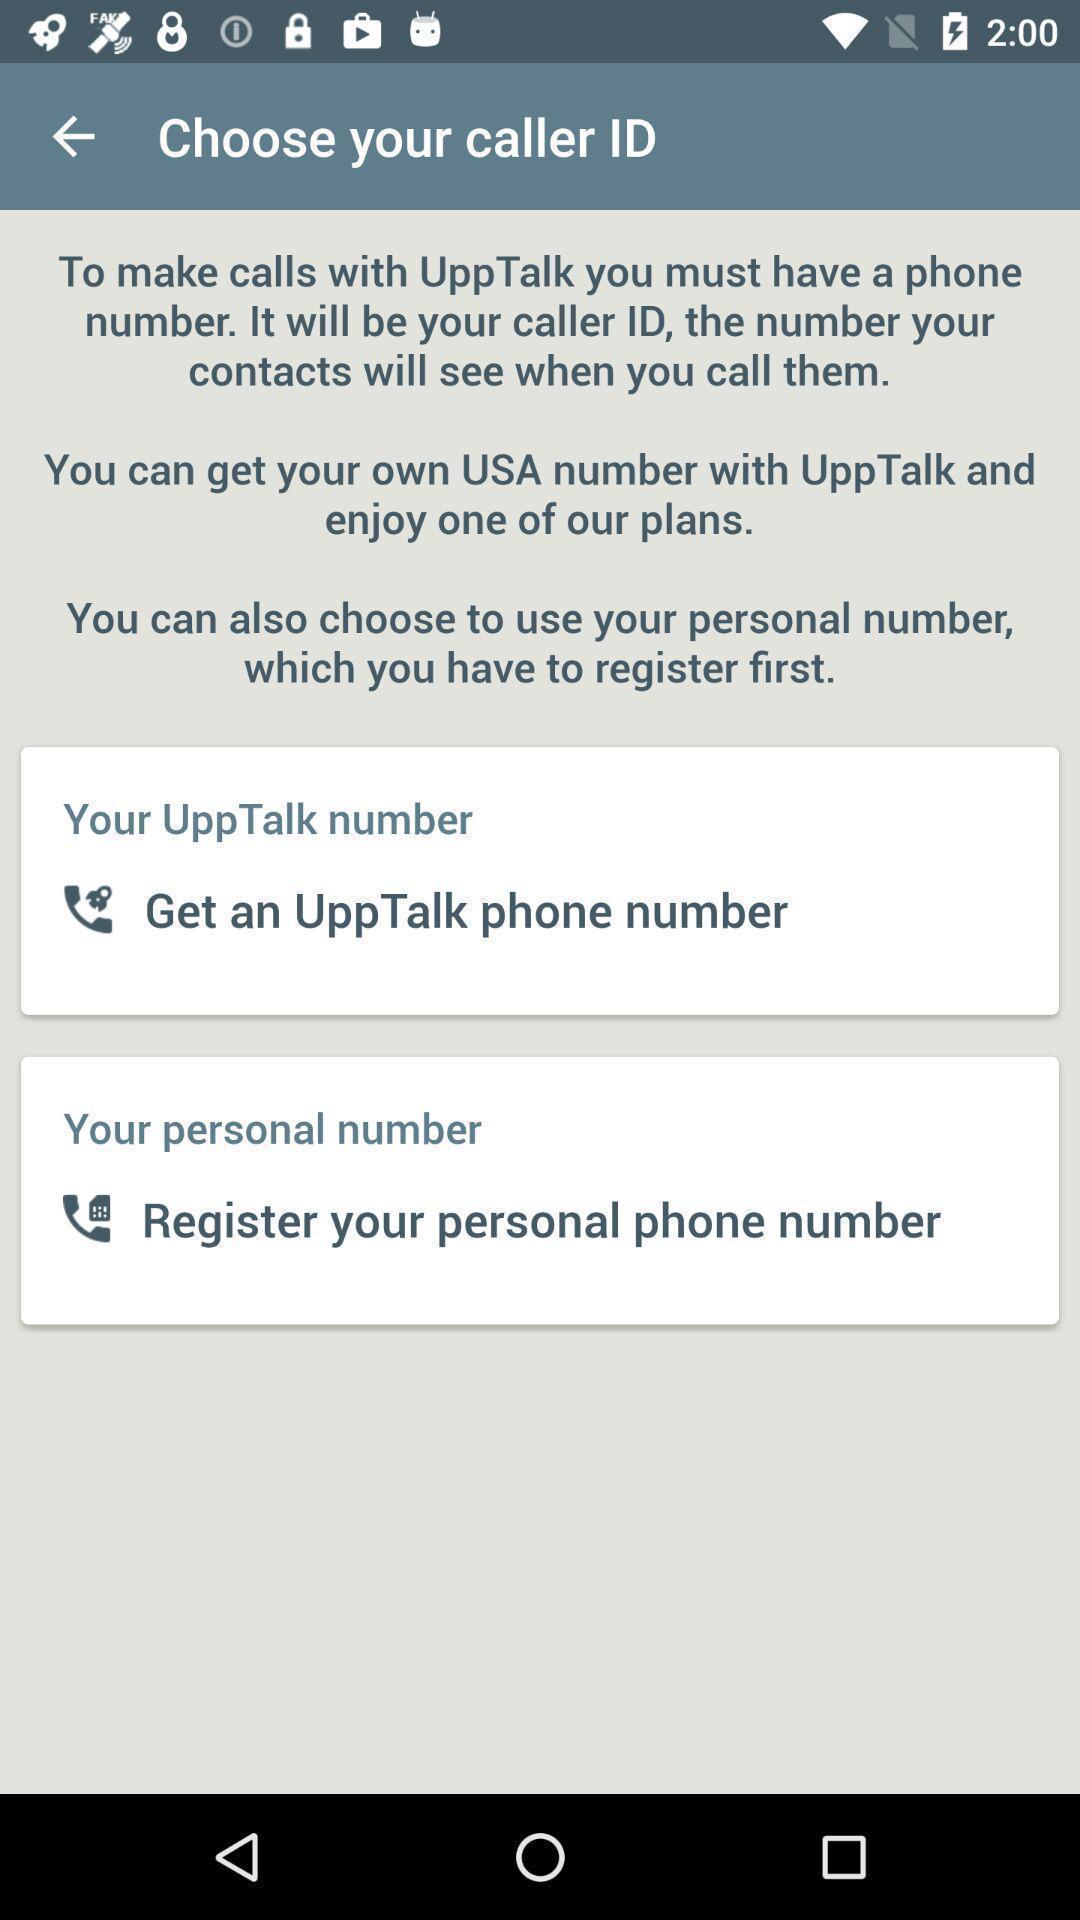Provide a detailed account of this screenshot. Page to choose your caller id. 